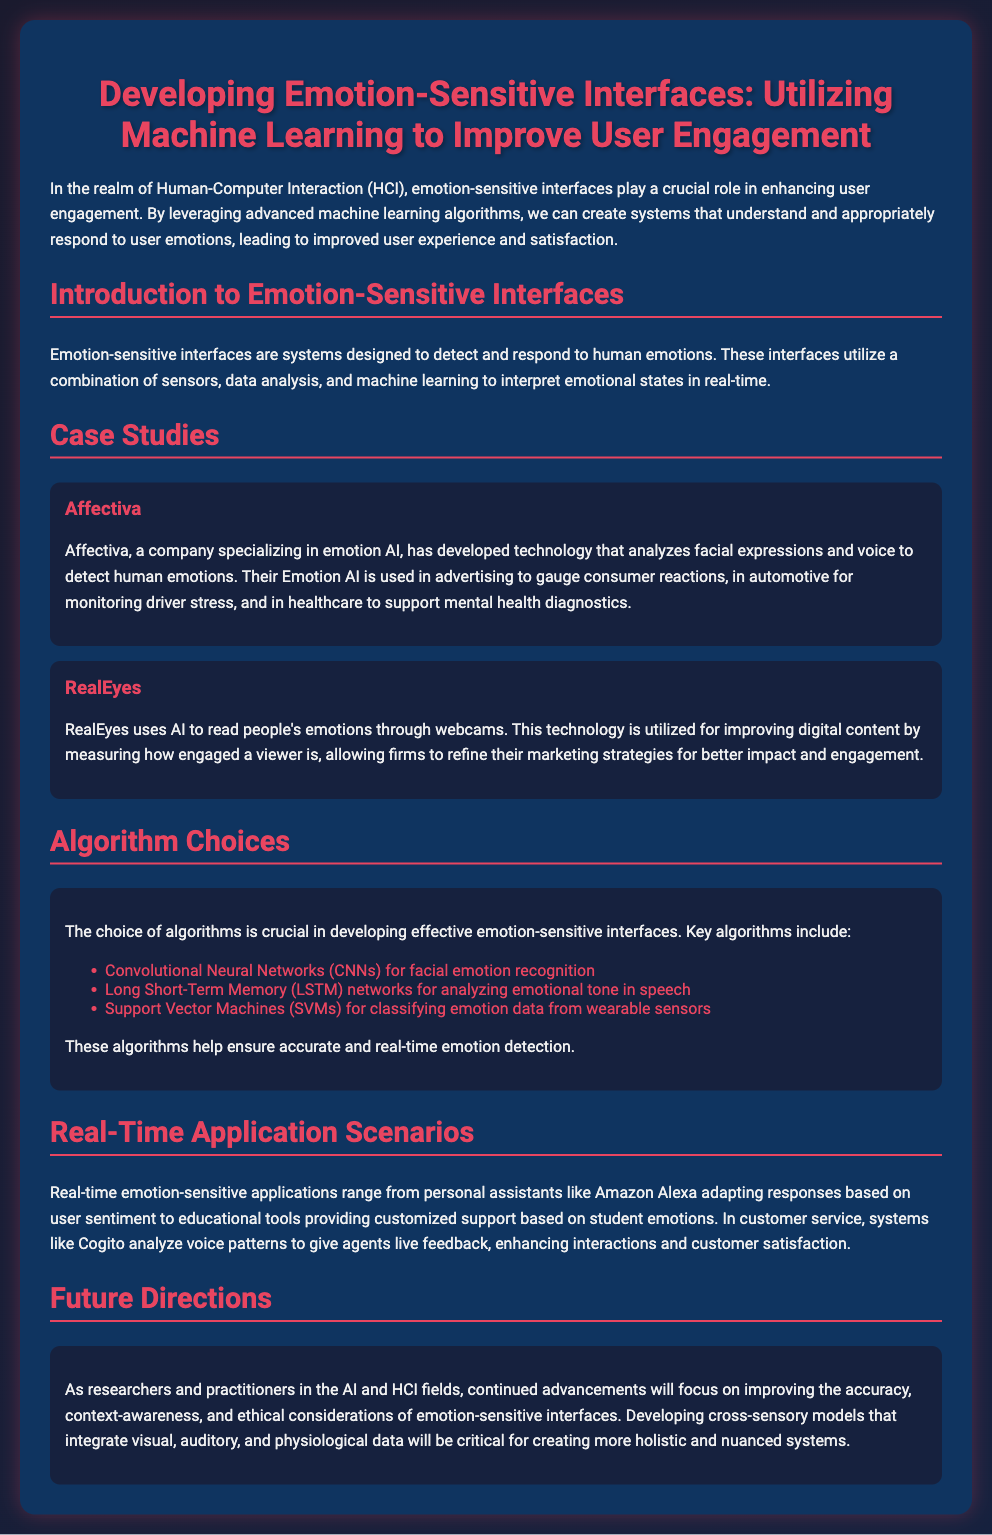what is the name of the company specializing in emotion AI? The company mentioned that specializes in emotion AI is Affectiva.
Answer: Affectiva what type of networks are used for analyzing emotional tone in speech? The document describes Long Short-Term Memory networks as being used for analyzing emotional tone in speech.
Answer: Long Short-Term Memory networks which algorithm is used for facial emotion recognition? The document states that Convolutional Neural Networks are used for facial emotion recognition.
Answer: Convolutional Neural Networks what technology does RealEyes use to read people's emotions? The document mentions that RealEyes uses AI to read people's emotions through webcams.
Answer: AI through webcams name one application scenario for emotion-sensitive interfaces. The document lists personal assistants like Amazon Alexa as one application scenario for emotion-sensitive interfaces.
Answer: Amazon Alexa what is a key focus for future directions in emotion-sensitive interfaces? The document indicates that improving context-awareness is a key focus for future directions in emotion-sensitive interfaces.
Answer: Context-awareness how many case studies are presented in the slide? The document presents two case studies, Affectiva and RealEyes.
Answer: Two what role do emotion-sensitive interfaces play in HCI? The document emphasizes the role of emotion-sensitive interfaces in enhancing user engagement in HCI.
Answer: Enhancing user engagement 